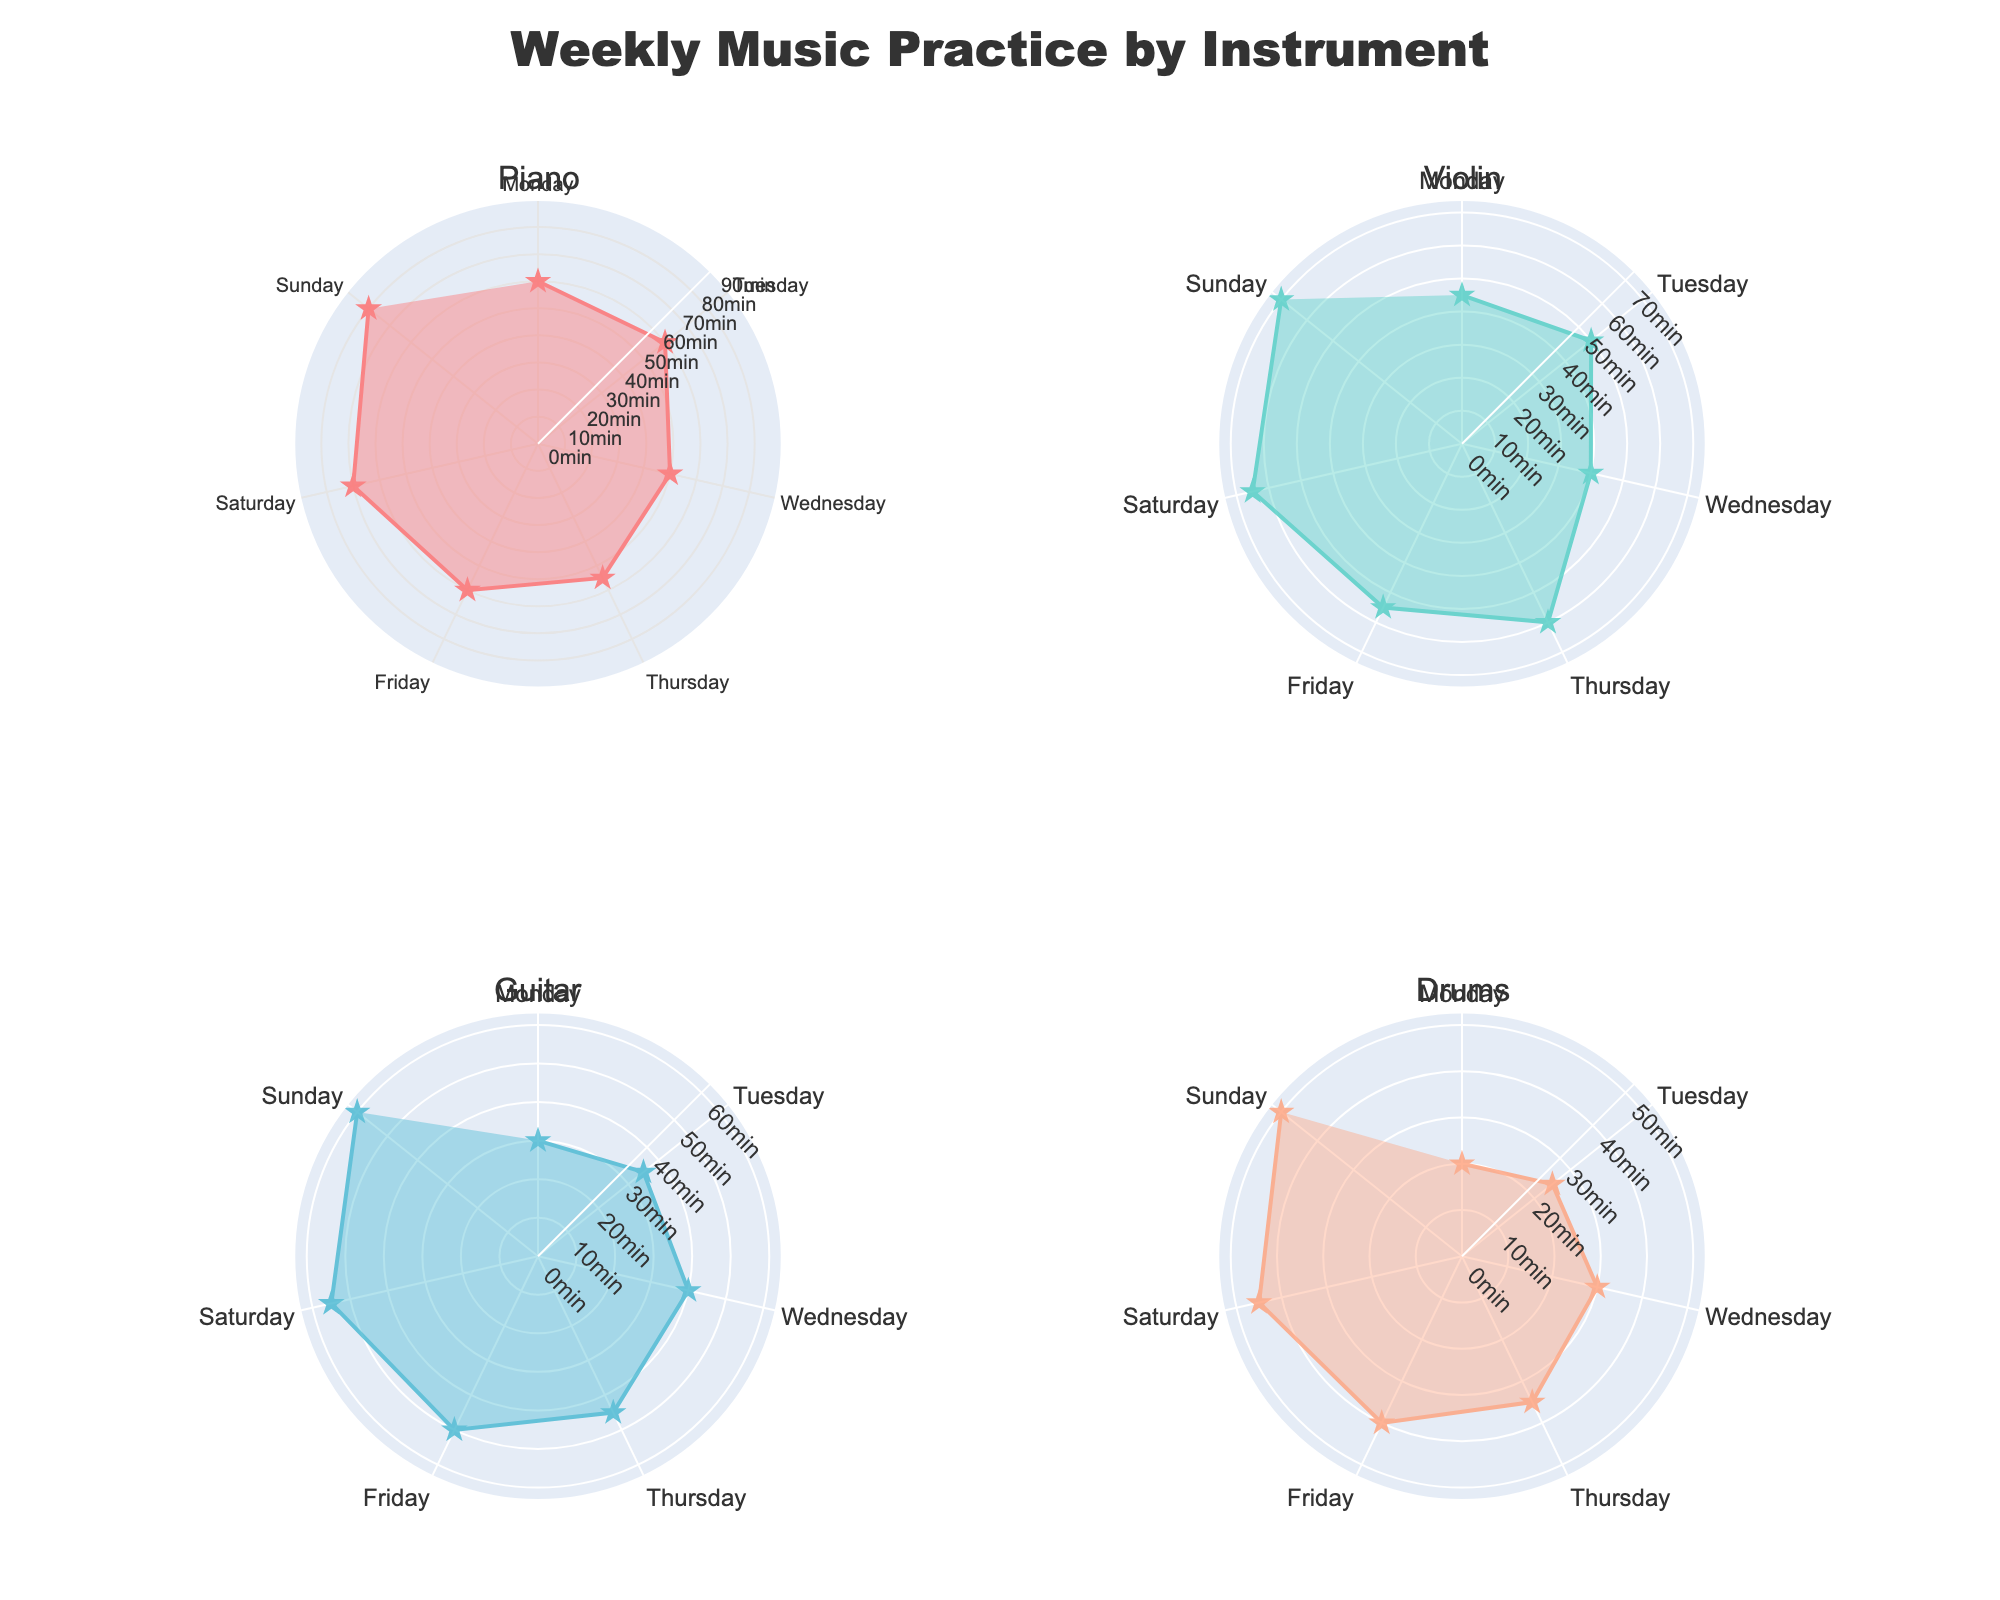What is the title of the figure? The title of the figure is prominently displayed at the top of the plot and reads "Weekly Music Practice by Instrument".
Answer: Weekly Music Practice by Instrument Which instrument has the highest average daily practice time? To determine the average daily practice time for each instrument, you sum the daily practice times and divide by the number of days. Piano: (60+60+50+55+60+70+80)/7 = 62.14, Violin: (45+50+40+60+55+65+70)/7 = 55, Guitar: (30+35+40+45+50+55+60)/7 = 45, Drums: (20+25+30+35+40+45+50)/7 = 35.85. Therefore, Piano has the highest average daily practice time.
Answer: Piano On which day does the Violin practice the most? By referencing the polar plot for the Violin, we see that the highest point on the radial axis corresponds to Sunday, where the practice time is 70 minutes.
Answer: Sunday Which instrument has the most consistent practice time across the week? The most consistent practice time can be identified by looking for the instrument that shows the least fluctuation in the polar plot. The Guitar's radial points form a relatively even shape with no drastic peaks or drops, indicating consistency.
Answer: Guitar How much more time does the Piano practice on Sunday compared to Monday? From the polar plot, the practice time for Piano on Sunday is 80 minutes and on Monday it is 60 minutes. The difference is 80 - 60.
Answer: 20 minutes What is the combined practice time for Guitar on Monday and Wednesday? Referring to the radial values for Guitar, on Monday it is 30 minutes and on Wednesday it is 40 minutes. Summing these gives you 30 + 40.
Answer: 70 minutes Which day has the lowest practice time for Drums? Looking at the radial points for Drums, the lowest value, which is 20 minutes, occurs on Monday.
Answer: Monday How does the practice duration for Violin on Thursday compare with that of Guitar on the same day? From the polar plots, the practice time for Violin on Thursday is 60 minutes and for Guitar on Thursday is 45 minutes. Therefore, Violin practice time is longer.
Answer: Violin is longer by 15 minutes What's the total practice time for Piano on weekdays (Monday to Friday)? Summing the radial values for Piano from Monday to Friday: 60 + 60 + 50 + 55 + 60.
Answer: 285 minutes Which instrument shows the greatest variation in practice time across the week? The instrument with the greatest variation will have the most drastic differences between its highest and lowest points on the polar plot. Drums show the greatest variation from 20 minutes (Monday) to 50 minutes (Sunday), a range of 30 minutes.
Answer: Drums 